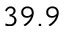Convert formula to latex. <formula><loc_0><loc_0><loc_500><loc_500>3 9 . 9</formula> 